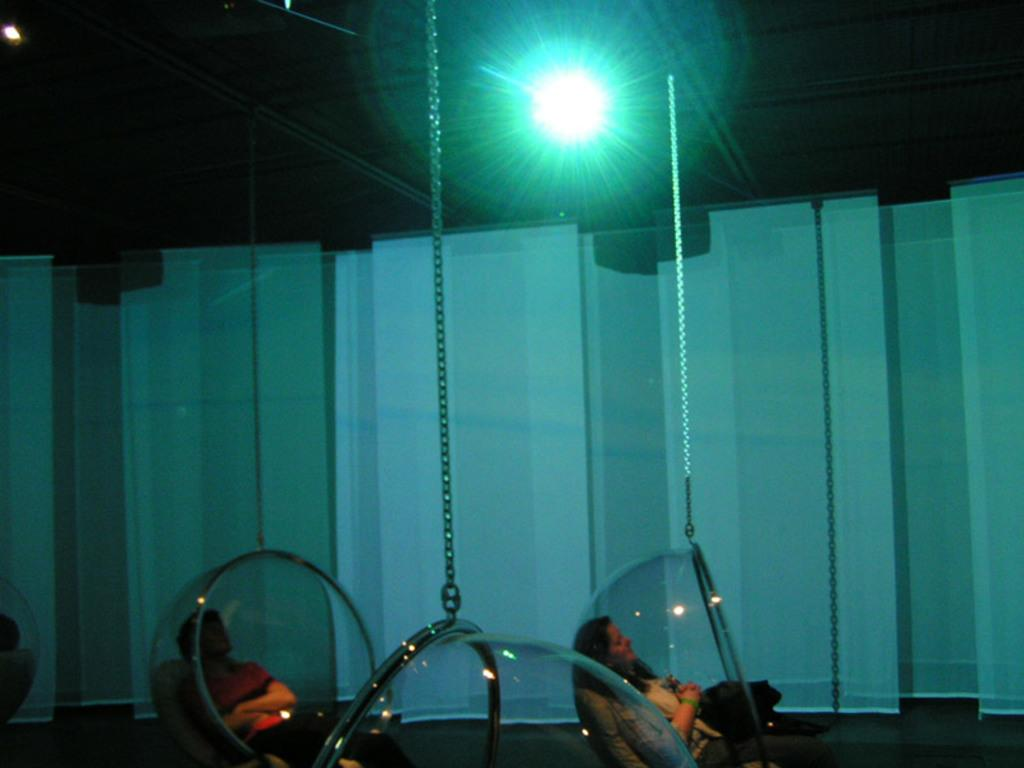What are the people sitting in, as described in the image? The people are sitting in glass things. What type of objects are attached to the glass things? Chains are visible in the image, attached to the glass things. What can be seen providing illumination in the image? There is a light in the image. How would you describe the overall lighting in the image? The image appears to be slightly dark. What flavor of cable can be seen in the image? There is no cable present in the image, and therefore no flavor can be associated with it. 